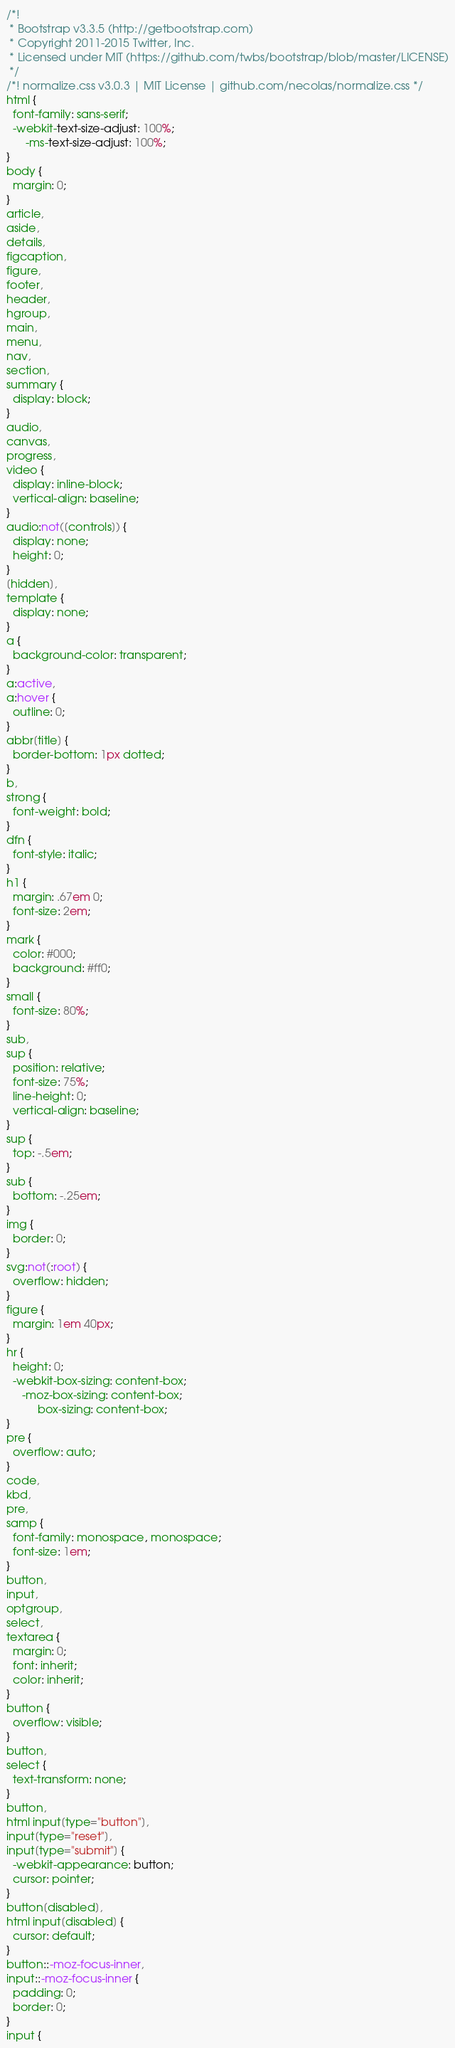<code> <loc_0><loc_0><loc_500><loc_500><_CSS_>/*!
 * Bootstrap v3.3.5 (http://getbootstrap.com)
 * Copyright 2011-2015 Twitter, Inc.
 * Licensed under MIT (https://github.com/twbs/bootstrap/blob/master/LICENSE)
 */
/*! normalize.css v3.0.3 | MIT License | github.com/necolas/normalize.css */
html {
  font-family: sans-serif;
  -webkit-text-size-adjust: 100%;
      -ms-text-size-adjust: 100%;
}
body {
  margin: 0;
}
article,
aside,
details,
figcaption,
figure,
footer,
header,
hgroup,
main,
menu,
nav,
section,
summary {
  display: block;
}
audio,
canvas,
progress,
video {
  display: inline-block;
  vertical-align: baseline;
}
audio:not([controls]) {
  display: none;
  height: 0;
}
[hidden],
template {
  display: none;
}
a {
  background-color: transparent;
}
a:active,
a:hover {
  outline: 0;
}
abbr[title] {
  border-bottom: 1px dotted;
}
b,
strong {
  font-weight: bold;
}
dfn {
  font-style: italic;
}
h1 {
  margin: .67em 0;
  font-size: 2em;
}
mark {
  color: #000;
  background: #ff0;
}
small {
  font-size: 80%;
}
sub,
sup {
  position: relative;
  font-size: 75%;
  line-height: 0;
  vertical-align: baseline;
}
sup {
  top: -.5em;
}
sub {
  bottom: -.25em;
}
img {
  border: 0;
}
svg:not(:root) {
  overflow: hidden;
}
figure {
  margin: 1em 40px;
}
hr {
  height: 0;
  -webkit-box-sizing: content-box;
     -moz-box-sizing: content-box;
          box-sizing: content-box;
}
pre {
  overflow: auto;
}
code,
kbd,
pre,
samp {
  font-family: monospace, monospace;
  font-size: 1em;
}
button,
input,
optgroup,
select,
textarea {
  margin: 0;
  font: inherit;
  color: inherit;
}
button {
  overflow: visible;
}
button,
select {
  text-transform: none;
}
button,
html input[type="button"],
input[type="reset"],
input[type="submit"] {
  -webkit-appearance: button;
  cursor: pointer;
}
button[disabled],
html input[disabled] {
  cursor: default;
}
button::-moz-focus-inner,
input::-moz-focus-inner {
  padding: 0;
  border: 0;
}
input {</code> 